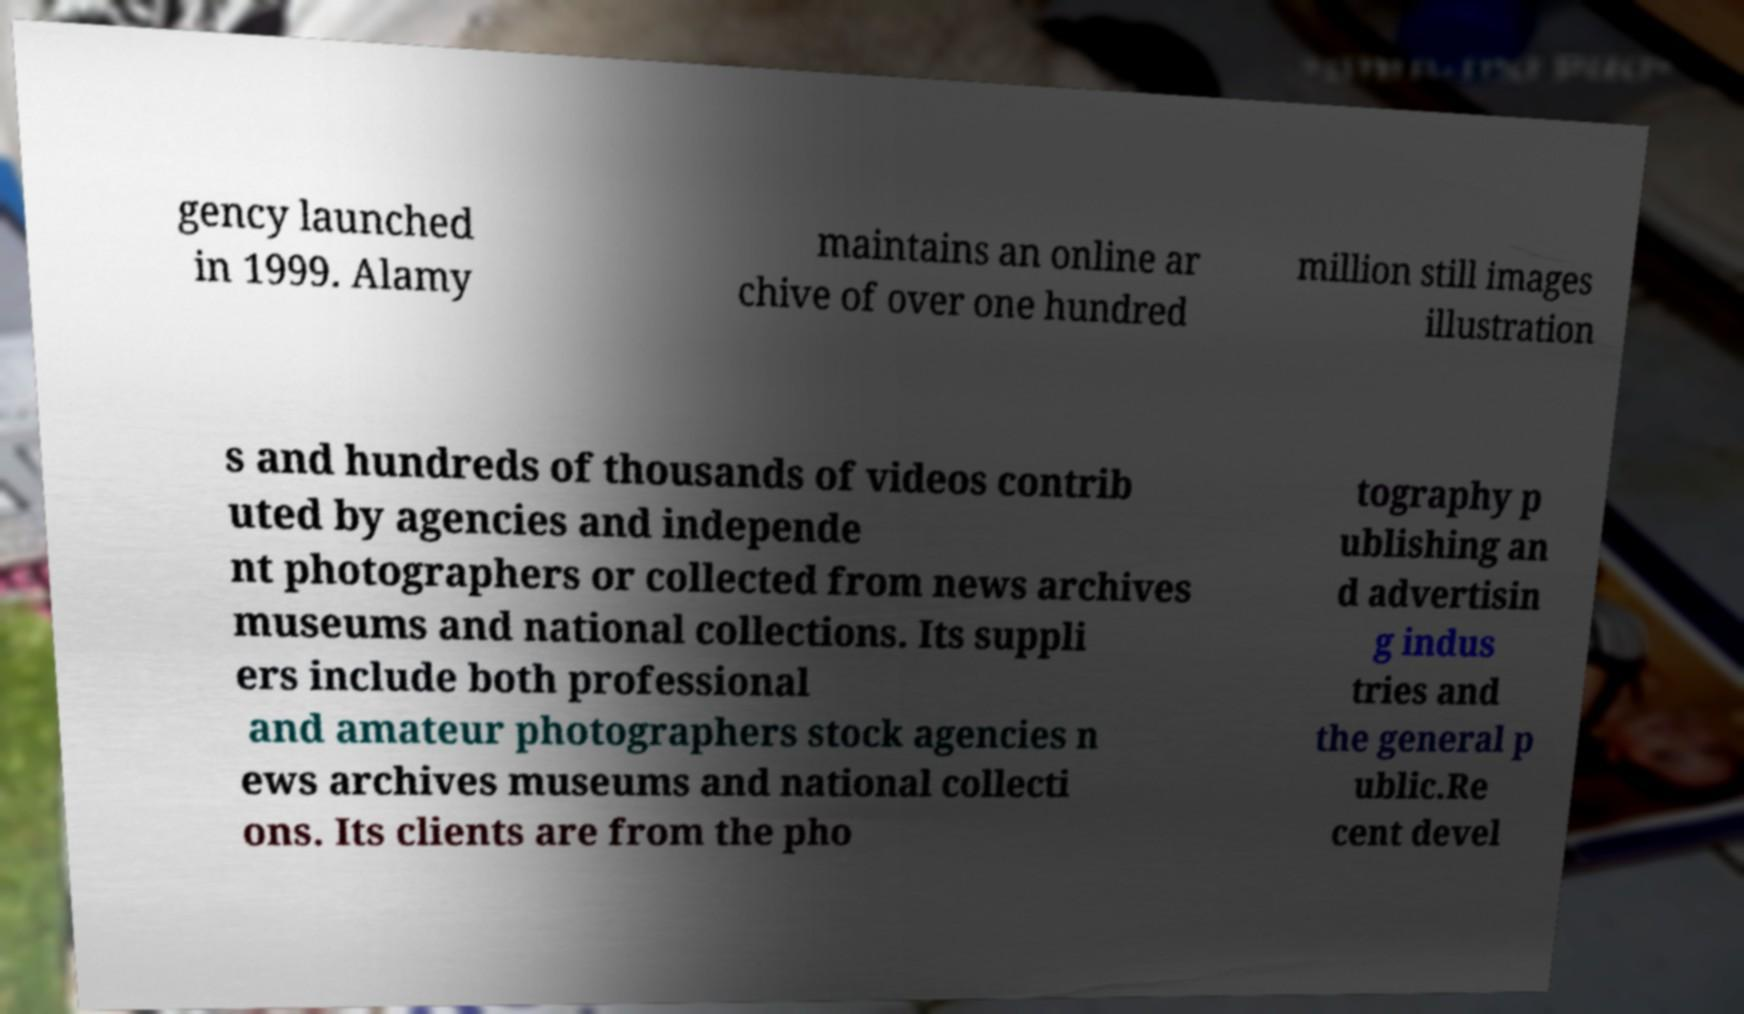For documentation purposes, I need the text within this image transcribed. Could you provide that? gency launched in 1999. Alamy maintains an online ar chive of over one hundred million still images illustration s and hundreds of thousands of videos contrib uted by agencies and independe nt photographers or collected from news archives museums and national collections. Its suppli ers include both professional and amateur photographers stock agencies n ews archives museums and national collecti ons. Its clients are from the pho tography p ublishing an d advertisin g indus tries and the general p ublic.Re cent devel 